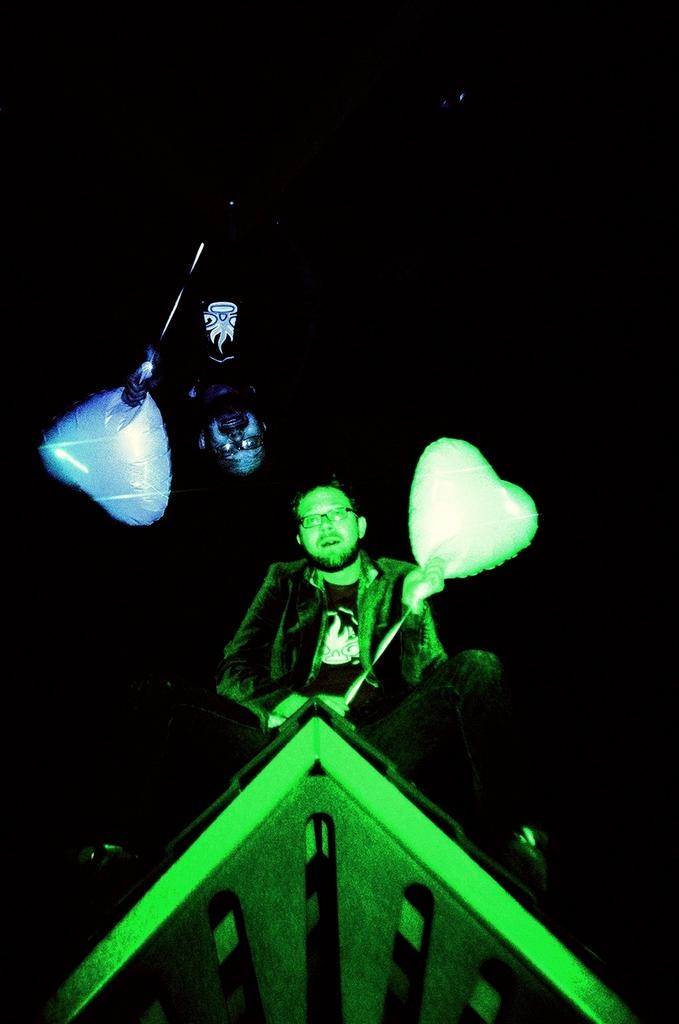How many people are in the image? There are two persons in the image. What are the persons holding in the image? The persons are holding balloons. What can be observed about the background of the image? The background of the image is dark. What color is the sister's hair in the image? There is no mention of a sister in the image, and therefore no information about her hair color can be provided. 